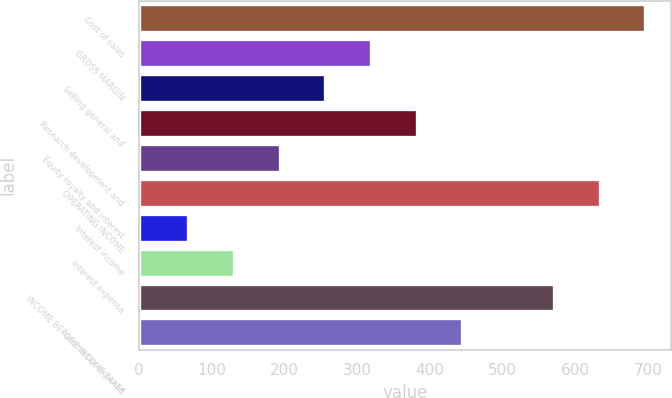<chart> <loc_0><loc_0><loc_500><loc_500><bar_chart><fcel>Cost of sales<fcel>GROSS MARGIN<fcel>Selling general and<fcel>Research development and<fcel>Equity royalty and interest<fcel>OPERATING INCOME<fcel>Interest income<fcel>Interest expense<fcel>INCOME BEFORE INCOME TAXES<fcel>Income tax expense<nl><fcel>695.8<fcel>319<fcel>256.2<fcel>381.8<fcel>193.4<fcel>633<fcel>67.8<fcel>130.6<fcel>570.2<fcel>444.6<nl></chart> 